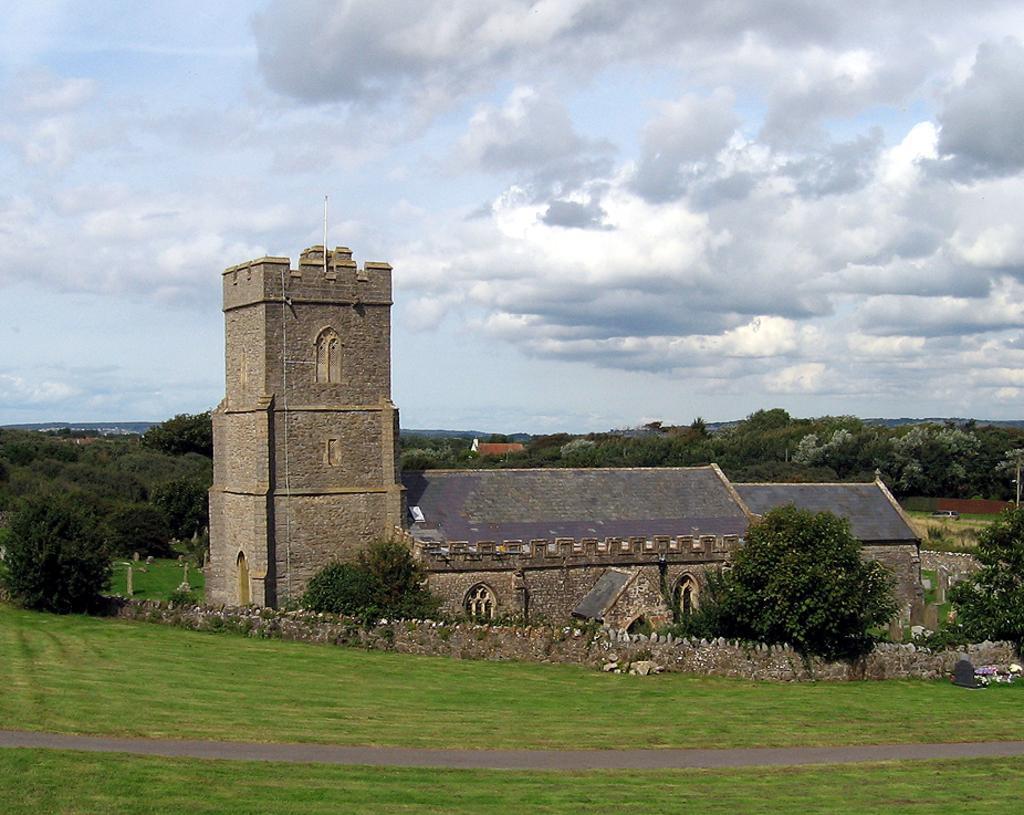Please provide a concise description of this image. In this image there is a house. Around the house there is a wall made of stones. In front of the wall there's grass on the ground. At the bottom there is a path. In the background there are trees, houses and mountains. At the top there is the sky. 